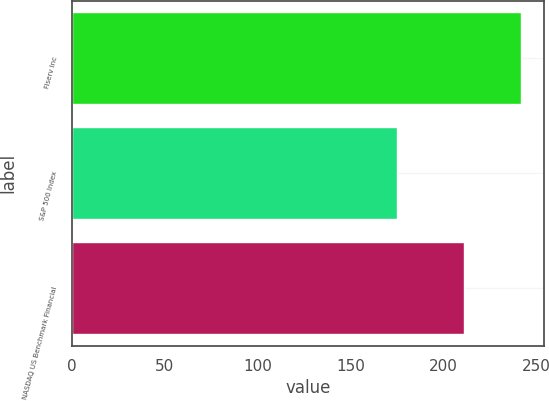Convert chart. <chart><loc_0><loc_0><loc_500><loc_500><bar_chart><fcel>Fiserv Inc<fcel>S&P 500 Index<fcel>NASDAQ US Benchmark Financial<nl><fcel>242<fcel>175<fcel>211<nl></chart> 